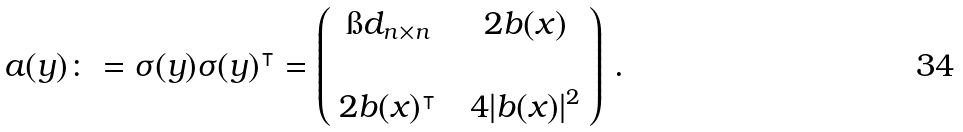Convert formula to latex. <formula><loc_0><loc_0><loc_500><loc_500>a ( y ) \colon = \sigma ( y ) \sigma ( y ) ^ { \intercal } = \left ( \begin{array} { c c c } \i d _ { n \times n } & & 2 b ( x ) \\ \\ 2 b ( x ) ^ { \intercal } & & 4 | b ( x ) | ^ { 2 } \end{array} \right ) \, .</formula> 